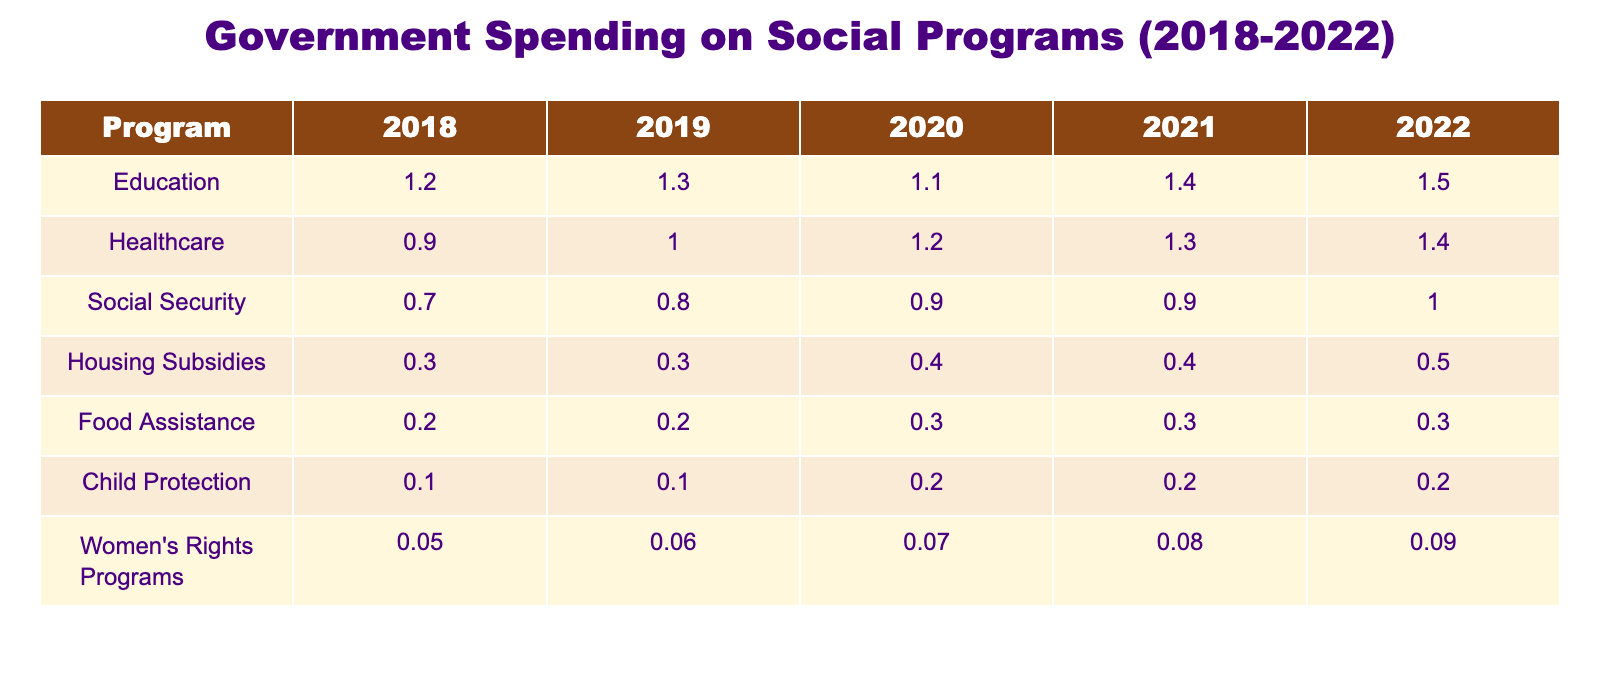What was the government spending on Education in 2022? In the table under the Education row for the year 2022, the value is 1.5.
Answer: 1.5 How much did the spending on Food Assistance increase from 2018 to 2022? The spending on Food Assistance in 2018 was 0.2, and in 2022 it was 0.3. The increase is 0.3 - 0.2 = 0.1.
Answer: 0.1 Is the spending on Women's Rights Programs higher in 2021 than in 2020? In 2021, the spending was 0.08, and in 2020, it was 0.07. Since 0.08 is greater than 0.07, the statement is true.
Answer: Yes What is the total spending on Social Security from 2018 to 2022? Adding the spending amounts for Social Security: 0.7 + 0.8 + 0.9 + 0.9 + 1.0 = 4.3.
Answer: 4.3 Which program had the highest amount allocated in 2019? In 2019, the spending for each program is: Education - 1.3, Healthcare - 1.0, Social Security - 0.8, Housing Subsidies - 0.3, Food Assistance - 0.2, Child Protection - 0.1, Women's Rights Programs - 0.06. Education had the highest spending of 1.3.
Answer: Education What was the average spending on Healthcare from 2018 to 2022? The amounts for Healthcare are: 0.9 (2018), 1.0 (2019), 1.2 (2020), 1.3 (2021), and 1.4 (2022). The total is 0.9 + 1.0 + 1.2 + 1.3 + 1.4 = 5.8. Dividing by 5 gives an average of 5.8 / 5 = 1.16.
Answer: 1.16 Did spending on Housing Subsidies ever reach 0.6 during the years 2018 to 2022? Observing the values for Housing Subsidies: 0.3 (2018), 0.3 (2019), 0.4 (2020), 0.4 (2021), and 0.5 (2022). The highest recorded value is 0.5, thus it never reached 0.6.
Answer: No What is the growth rate of spending on Child Protection from 2018 to 2022? The spending on Child Protection in 2018 was 0.1 and in 2022 it was 0.2. The growth amount is 0.2 - 0.1 = 0.1. To calculate the growth rate, divide the growth amount by the initial amount: 0.1 / 0.1 = 1. The growth rate is therefore 100%.
Answer: 100% 